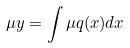Convert formula to latex. <formula><loc_0><loc_0><loc_500><loc_500>\mu y = \int \mu q ( x ) d x</formula> 